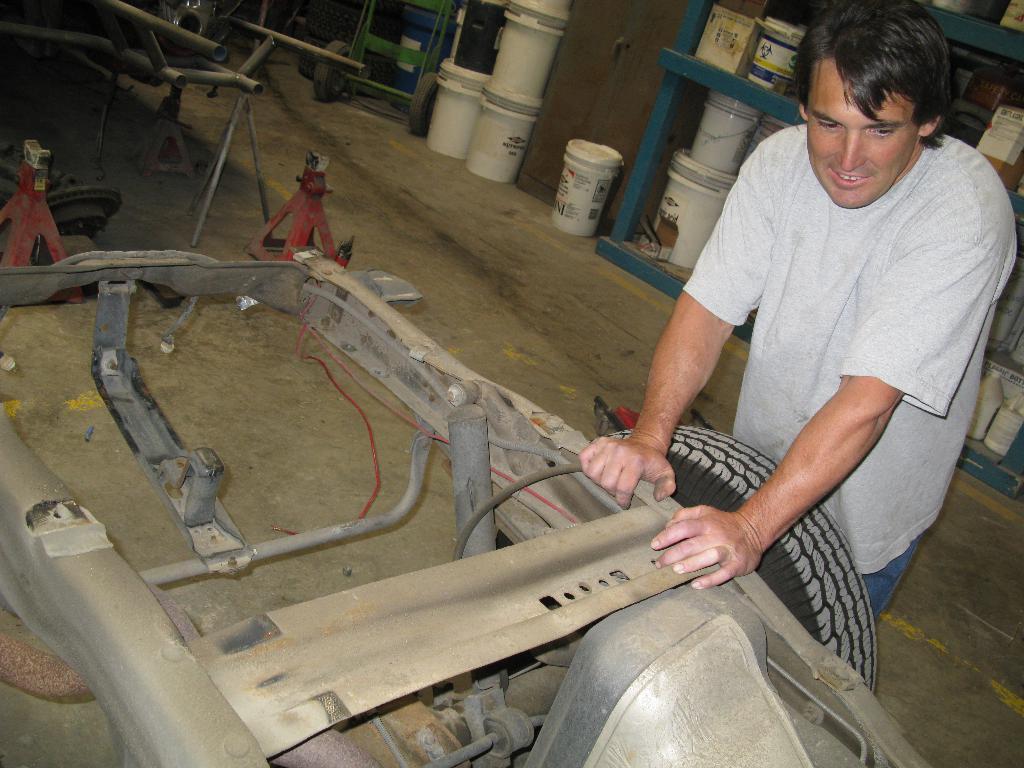Can you describe this image briefly? In this picture I can see a man is standing in front of a vehicle. In the background I can see buckets in a shelf. The man is wearing white color t shirt and pant. I can also see metal rods and some other objects on the ground. 